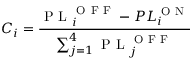<formula> <loc_0><loc_0><loc_500><loc_500>C _ { i } = \frac { P L _ { i } ^ { O F F } - P L _ { i } ^ { O N } } { \sum _ { j = 1 } ^ { 4 } P L _ { j } ^ { O F F } }</formula> 